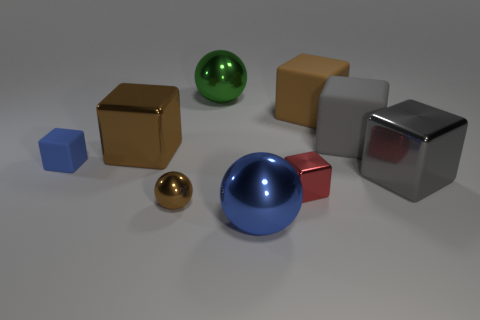Are there any other things that have the same size as the brown shiny block?
Provide a short and direct response. Yes. How many rubber blocks are to the right of the gray block behind the tiny blue cube?
Give a very brief answer. 0. Is there anything else that is the same material as the tiny sphere?
Give a very brief answer. Yes. The gray cube that is behind the small block on the left side of the big blue ball that is on the right side of the small ball is made of what material?
Your answer should be very brief. Rubber. There is a big thing that is in front of the blue rubber object and behind the big blue ball; what is it made of?
Your response must be concise. Metal. What number of other big rubber things are the same shape as the red thing?
Your answer should be very brief. 2. What size is the metallic thing that is to the right of the matte thing behind the gray rubber block?
Provide a succinct answer. Large. There is a small block that is behind the gray metallic thing; is its color the same as the big metallic cube that is right of the brown ball?
Keep it short and to the point. No. There is a large metal sphere that is to the right of the big green metal thing that is behind the brown rubber cube; how many blocks are to the left of it?
Keep it short and to the point. 2. What number of objects are left of the large brown rubber cube and right of the small sphere?
Provide a short and direct response. 3. 